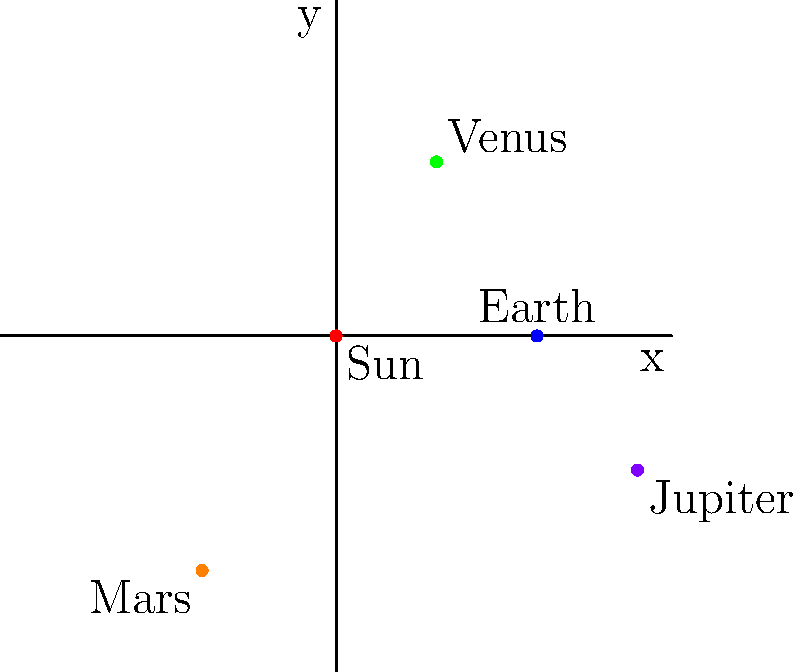As an iOS developer working on an astronomy app, you need to plot the positions of planets in the solar system on a 2D coordinate plane. Given the diagram above, which shows the Sun at the origin (0,0) and four planets plotted around it, what would be the Swift code to calculate the distance between Venus and Mars using their coordinates? To solve this problem, we'll follow these steps:

1. Identify the coordinates of Venus and Mars from the diagram:
   Venus: (1.5, 2.6)
   Mars: (-2, -3.5)

2. Recall the distance formula between two points (x1, y1) and (x2, y2):
   $$ d = \sqrt{(x_2 - x_1)^2 + (y_2 - y_1)^2} $$

3. In Swift, we can implement this formula using the `pow()` function for squaring and `sqrt()` for square root. We'll also use `Double` for precision.

4. The Swift code to calculate the distance would be:

```swift
import Foundation

let venusX: Double = 1.5
let venusY: Double = 2.6
let marsX: Double = -2
let marsY: Double = -3.5

let distance = sqrt(pow(marsX - venusX, 2) + pow(marsY - venusY, 2))
```

5. This code creates `Double` variables for the x and y coordinates of Venus and Mars, then applies the distance formula using `pow()` and `sqrt()` functions.

6. The `distance` variable will contain the result of the calculation, which is the distance between Venus and Mars on the 2D plane.
Answer: sqrt(pow(marsX - venusX, 2) + pow(marsY - venusY, 2)) 